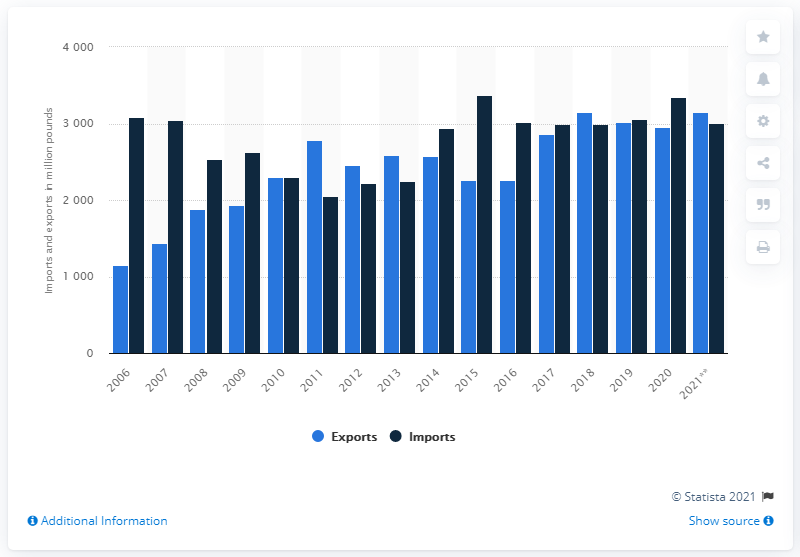Draw attention to some important aspects in this diagram. In 2015, a significant amount of beef and veal was exported to the United States. Specifically, approximately 2,300 metric tons of beef and veal were exported to the United States. 